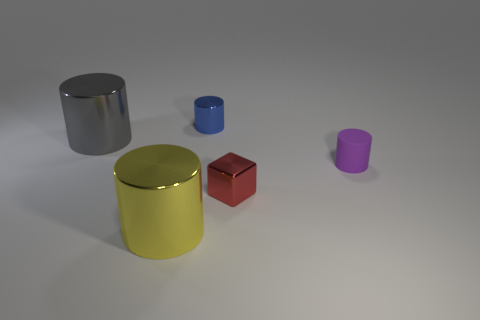Add 1 small blue metal things. How many objects exist? 6 Subtract all cylinders. How many objects are left? 1 Add 4 tiny blue metal cylinders. How many tiny blue metal cylinders exist? 5 Subtract 0 gray cubes. How many objects are left? 5 Subtract all small cyan matte objects. Subtract all rubber things. How many objects are left? 4 Add 1 tiny blocks. How many tiny blocks are left? 2 